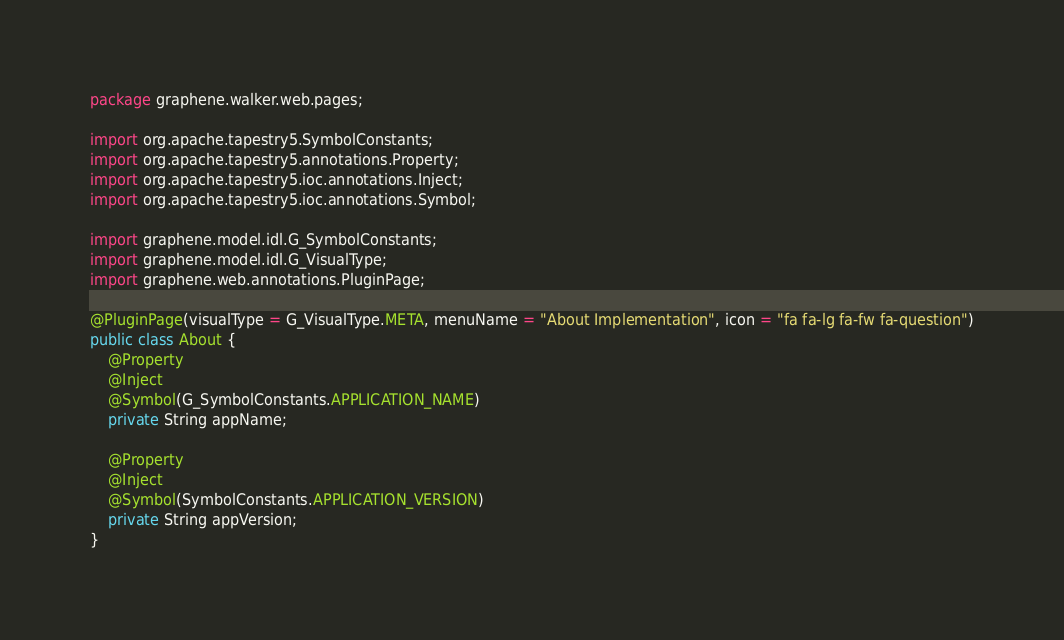<code> <loc_0><loc_0><loc_500><loc_500><_Java_>package graphene.walker.web.pages;

import org.apache.tapestry5.SymbolConstants;
import org.apache.tapestry5.annotations.Property;
import org.apache.tapestry5.ioc.annotations.Inject;
import org.apache.tapestry5.ioc.annotations.Symbol;

import graphene.model.idl.G_SymbolConstants;
import graphene.model.idl.G_VisualType;
import graphene.web.annotations.PluginPage;

@PluginPage(visualType = G_VisualType.META, menuName = "About Implementation", icon = "fa fa-lg fa-fw fa-question")
public class About {
	@Property
	@Inject
	@Symbol(G_SymbolConstants.APPLICATION_NAME)
	private String appName;

	@Property
	@Inject
	@Symbol(SymbolConstants.APPLICATION_VERSION)
	private String appVersion;
}
</code> 